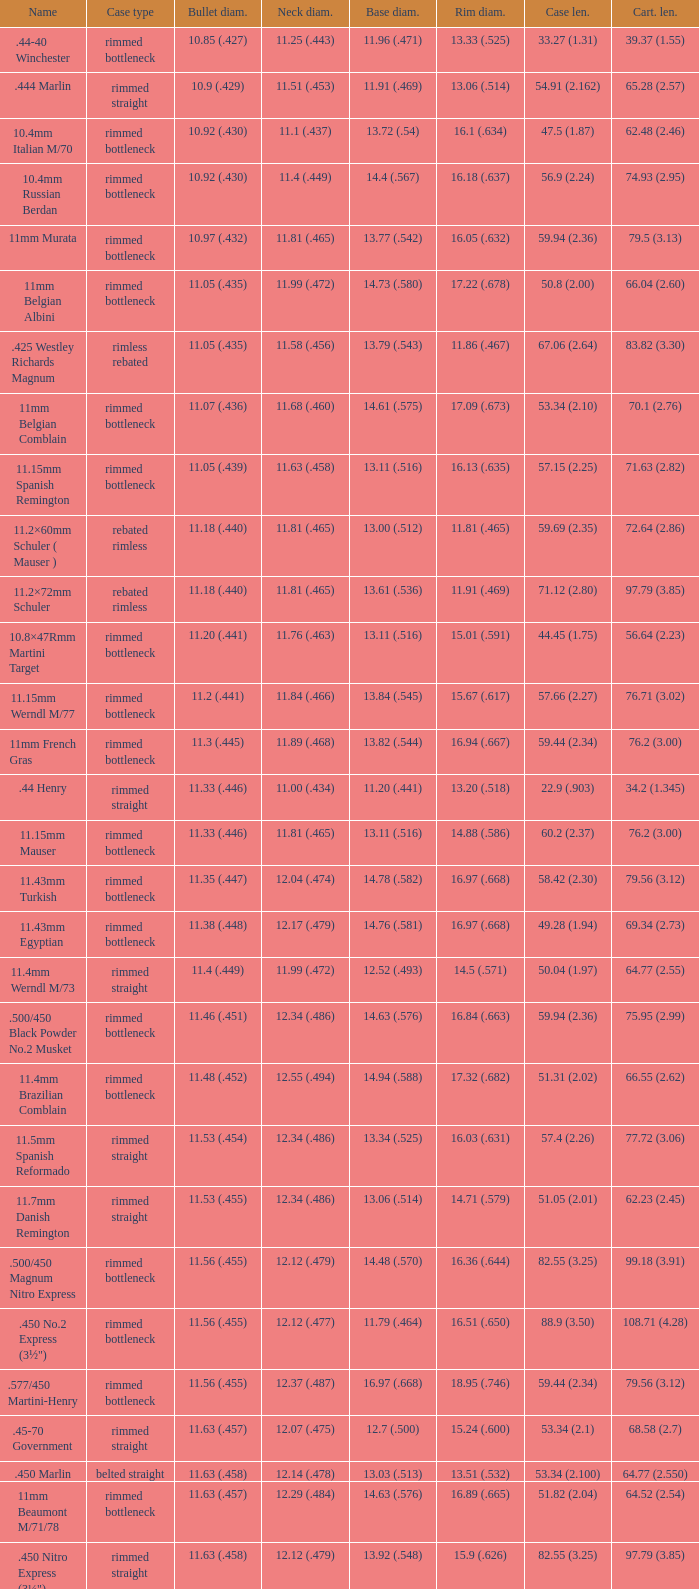Which Case length has a Rim diameter of 13.20 (.518)? 22.9 (.903). 